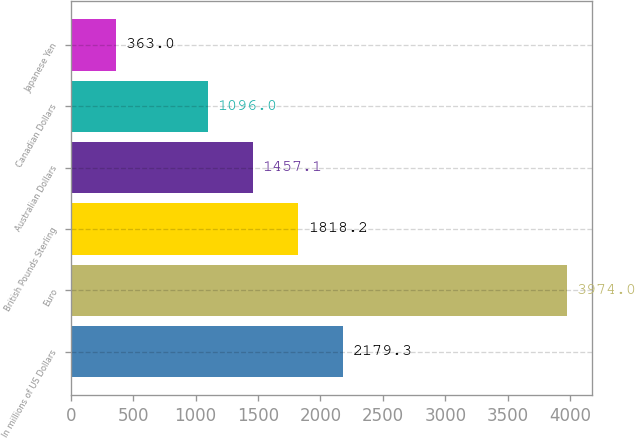Convert chart to OTSL. <chart><loc_0><loc_0><loc_500><loc_500><bar_chart><fcel>In millions of US Dollars<fcel>Euro<fcel>British Pounds Sterling<fcel>Australian Dollars<fcel>Canadian Dollars<fcel>Japanese Yen<nl><fcel>2179.3<fcel>3974<fcel>1818.2<fcel>1457.1<fcel>1096<fcel>363<nl></chart> 